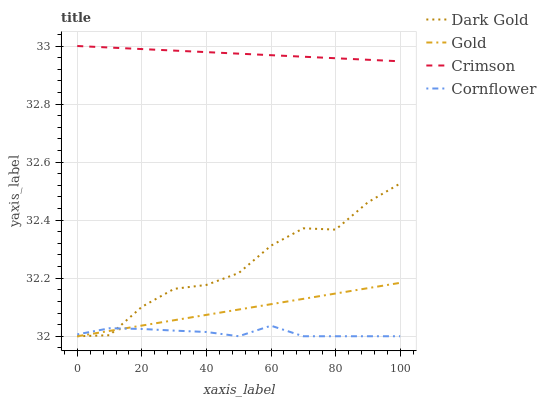Does Cornflower have the minimum area under the curve?
Answer yes or no. Yes. Does Crimson have the maximum area under the curve?
Answer yes or no. Yes. Does Gold have the minimum area under the curve?
Answer yes or no. No. Does Gold have the maximum area under the curve?
Answer yes or no. No. Is Gold the smoothest?
Answer yes or no. Yes. Is Dark Gold the roughest?
Answer yes or no. Yes. Is Cornflower the smoothest?
Answer yes or no. No. Is Cornflower the roughest?
Answer yes or no. No. Does Cornflower have the lowest value?
Answer yes or no. Yes. Does Crimson have the highest value?
Answer yes or no. Yes. Does Gold have the highest value?
Answer yes or no. No. Is Cornflower less than Crimson?
Answer yes or no. Yes. Is Crimson greater than Dark Gold?
Answer yes or no. Yes. Does Dark Gold intersect Gold?
Answer yes or no. Yes. Is Dark Gold less than Gold?
Answer yes or no. No. Is Dark Gold greater than Gold?
Answer yes or no. No. Does Cornflower intersect Crimson?
Answer yes or no. No. 